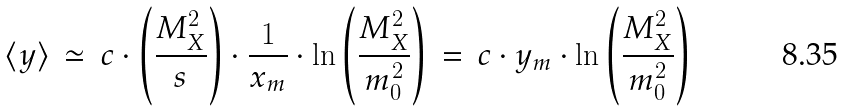Convert formula to latex. <formula><loc_0><loc_0><loc_500><loc_500>\langle y \rangle \, \simeq \, c \cdot \left ( \frac { M _ { X } ^ { 2 } } { s } \right ) \cdot \frac { 1 } { x _ { m } } \cdot \ln \left ( \frac { M _ { X } ^ { 2 } } { m _ { 0 } ^ { 2 } } \right ) \, = \, c \cdot y _ { m } \cdot \ln \left ( \frac { M _ { X } ^ { 2 } } { m _ { 0 } ^ { 2 } } \right )</formula> 